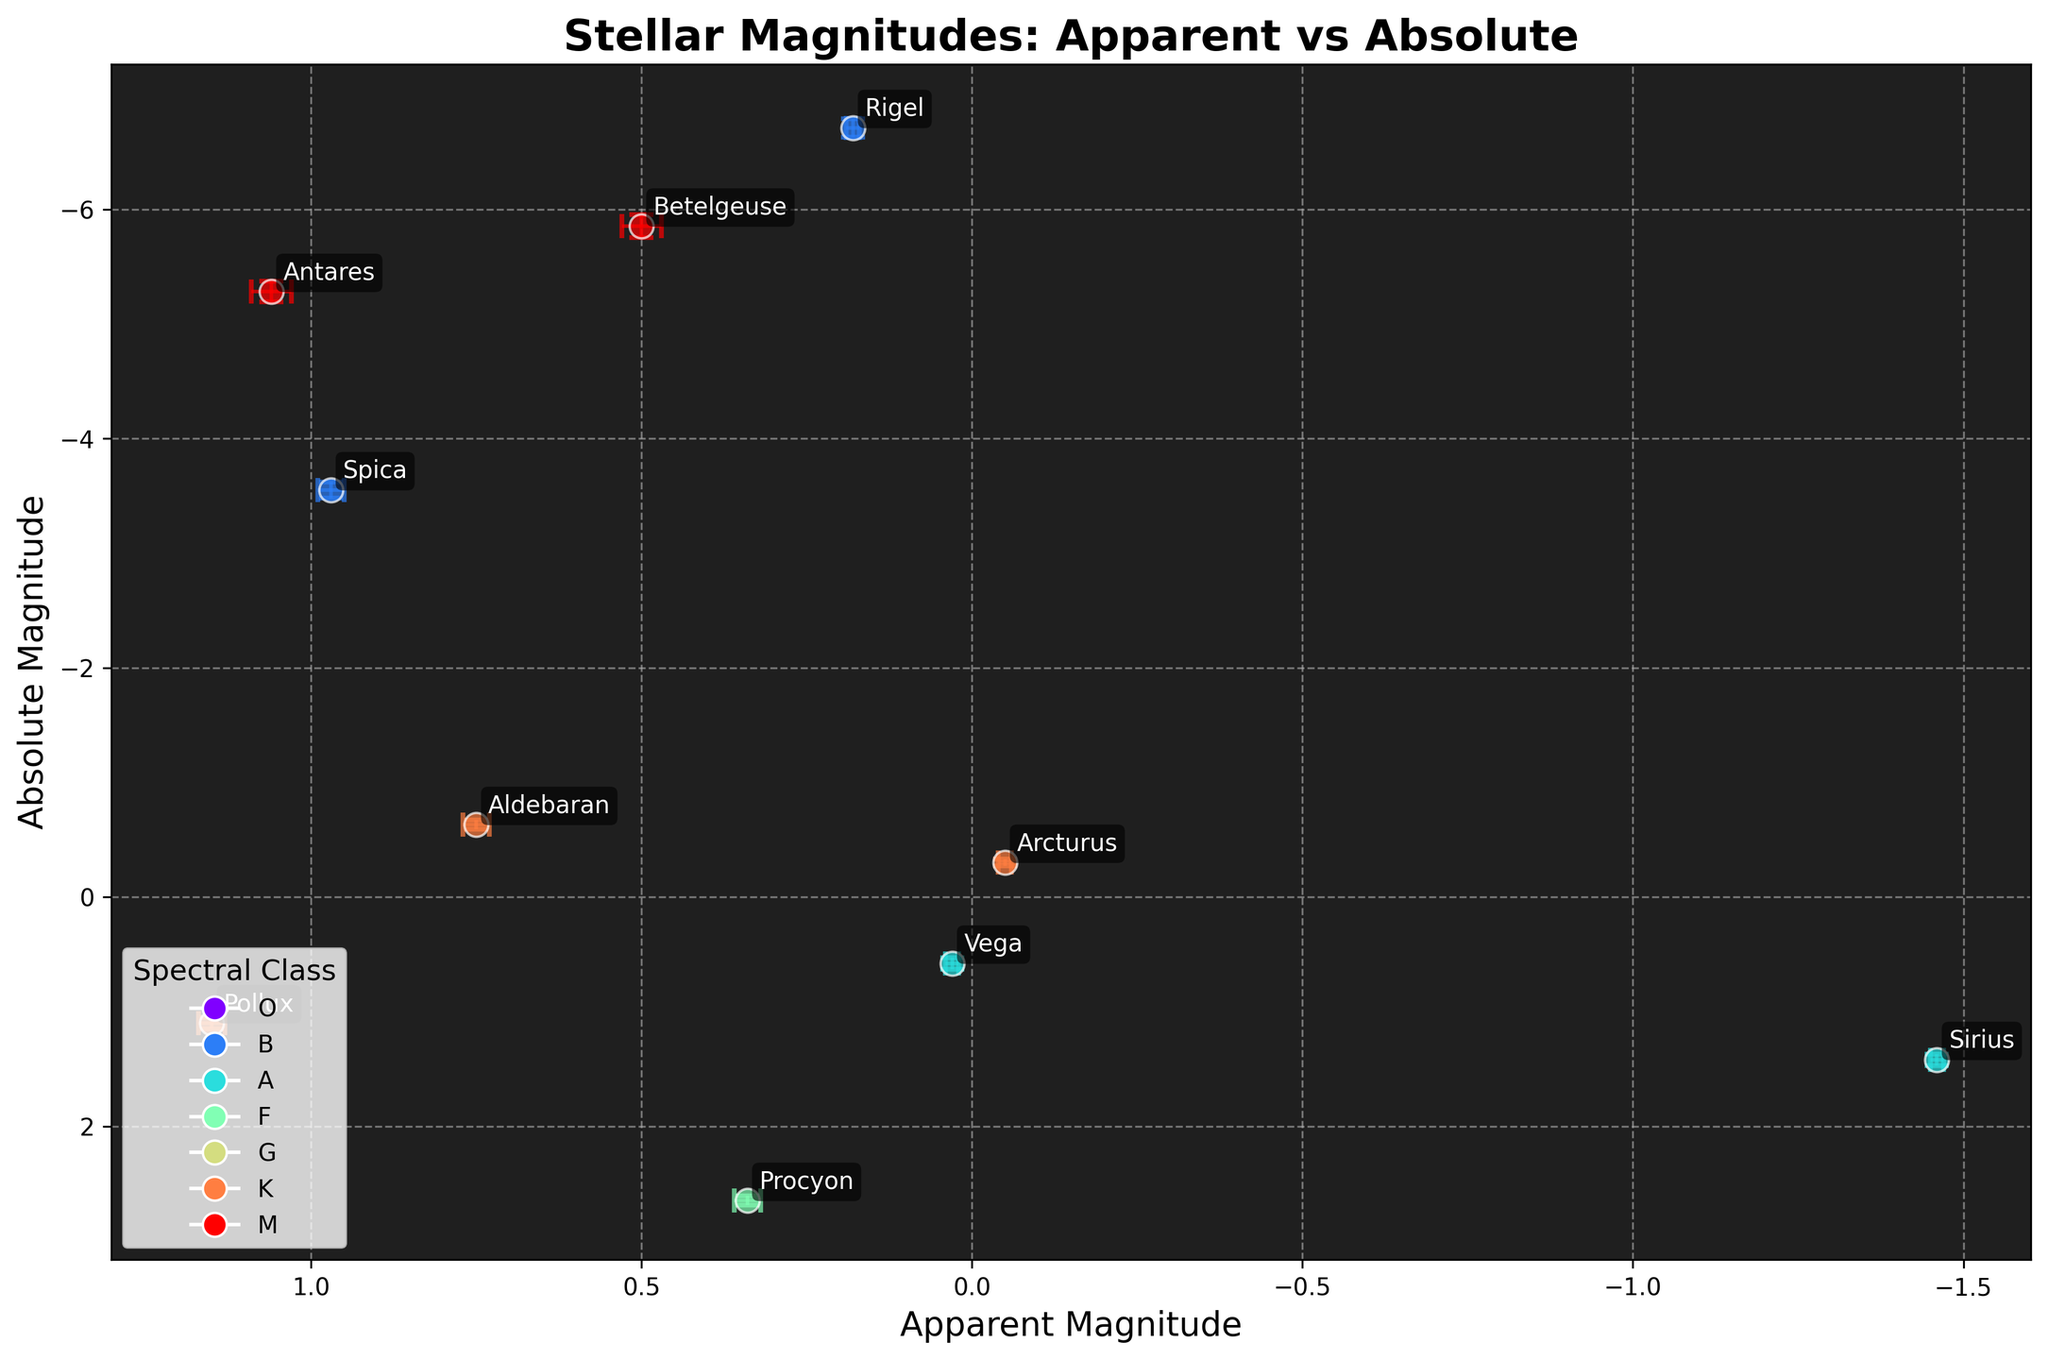What's the title of the plot? The title is displayed prominently at the top of the figure. It reads "Stellar Magnitudes: Apparent vs Absolute".
Answer: Stellar Magnitudes: Apparent vs Absolute How many stars are represented in the plot? By counting the labeled data points on the plot, there are 10 stars indicated, each with a name annotation.
Answer: 10 What are the x and y axes representing? The x-axis represents Apparent Magnitude, and the y-axis represents Absolute Magnitude, as indicated by their respective labels.
Answer: Apparent Magnitude and Absolute Magnitude Which star has the lowest Absolute Magnitude? The star with the lowest Absolute Magnitude is found by looking at the point with the smallest y-axis value. Rigel, with an Absolute Magnitude of -6.71, has the lowest Absolute Magnitude.
Answer: Rigel What is the Apparent Magnitude of Sirius? By locating Sirius on the plot, we can see its Apparent Magnitude, which is -1.46, clearly marked on the x-axis.
Answer: -1.46 Which star has the highest Apparent Magnitude? The highest Apparent Magnitude corresponds to the largest value on the x-axis. Pollux, with an Apparent Magnitude of +1.15, has the highest value.
Answer: Pollux What is the Average Absolute Magnitude of the stars in the plot? To find the average, sum the Absolute Magnitudes of all 10 stars and divide by 10. Calculation: (1.42 + -5.85 + 2.65 + -6.71 + -0.30 + 0.58 + -0.63 + -3.55 + -5.28 + 1.10) ÷ 10 = -1.157
Answer: -1.16 (rounded) Which star has the largest error bar for Absolute Magnitude? By assessing the length of the error bars on the y-axis, Betelgeuse with an error of ±0.1 has the largest Absolute Magnitude error bar.
Answer: Betelgeuse Which spectral class appears to have the most representation on this plot? By counting the different markers and their colors representing the spectral classes, class 'K' (with Arcturus, Aldebaran, and Pollux) appears most frequently.
Answer: K 